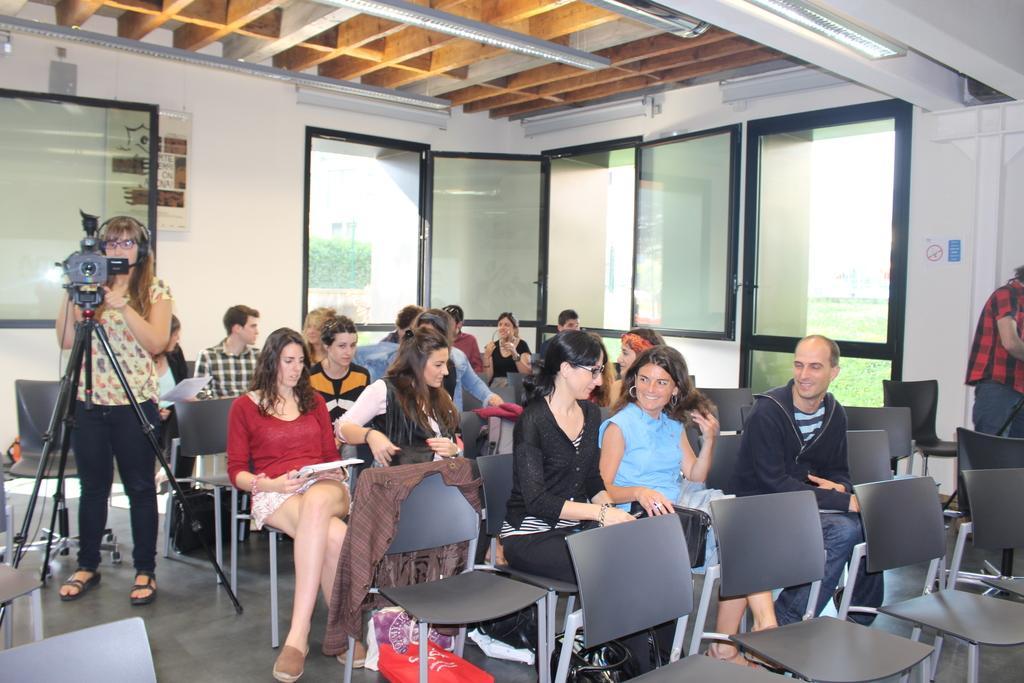Please provide a concise description of this image. In this image I see lot of people and most of them are sitting on the chairs and 2 of them are standing, I can also see that this woman is near the camera. In the background I see the wall and windows. 